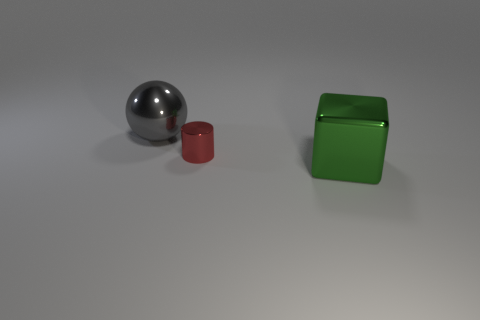Are there any cubes that have the same material as the red thing?
Provide a succinct answer. Yes. What is the color of the small shiny object?
Keep it short and to the point. Red. There is a metal thing behind the tiny thing; how big is it?
Offer a terse response. Large. There is a large object in front of the gray sphere; are there any cubes to the left of it?
Make the answer very short. No. What color is the metal thing that is the same size as the metallic block?
Your answer should be compact. Gray. Are there the same number of large green blocks that are to the right of the large green metallic object and big gray metallic objects on the right side of the gray metal thing?
Provide a succinct answer. Yes. What material is the large thing that is right of the big metallic thing that is behind the large green object?
Your response must be concise. Metal. How many objects are large shiny cubes or metallic cylinders?
Your answer should be very brief. 2. Are there fewer small red objects than things?
Offer a very short reply. Yes. The red cylinder that is made of the same material as the big cube is what size?
Give a very brief answer. Small. 